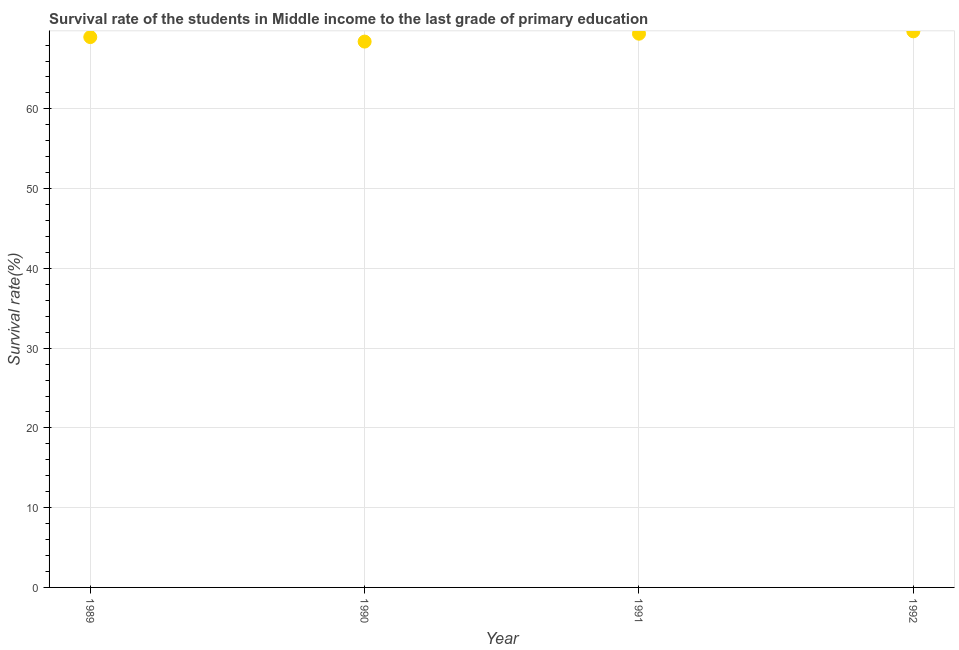What is the survival rate in primary education in 1990?
Ensure brevity in your answer.  68.44. Across all years, what is the maximum survival rate in primary education?
Your answer should be very brief. 69.72. Across all years, what is the minimum survival rate in primary education?
Your response must be concise. 68.44. In which year was the survival rate in primary education minimum?
Make the answer very short. 1990. What is the sum of the survival rate in primary education?
Offer a very short reply. 276.58. What is the difference between the survival rate in primary education in 1989 and 1991?
Offer a terse response. -0.42. What is the average survival rate in primary education per year?
Offer a very short reply. 69.15. What is the median survival rate in primary education?
Give a very brief answer. 69.21. In how many years, is the survival rate in primary education greater than 24 %?
Offer a very short reply. 4. What is the ratio of the survival rate in primary education in 1991 to that in 1992?
Provide a short and direct response. 1. Is the survival rate in primary education in 1989 less than that in 1990?
Offer a very short reply. No. What is the difference between the highest and the second highest survival rate in primary education?
Ensure brevity in your answer.  0.3. Is the sum of the survival rate in primary education in 1990 and 1991 greater than the maximum survival rate in primary education across all years?
Keep it short and to the point. Yes. What is the difference between the highest and the lowest survival rate in primary education?
Your answer should be compact. 1.29. Does the survival rate in primary education monotonically increase over the years?
Keep it short and to the point. No. How many dotlines are there?
Your answer should be very brief. 1. How many years are there in the graph?
Your answer should be very brief. 4. What is the difference between two consecutive major ticks on the Y-axis?
Provide a succinct answer. 10. Are the values on the major ticks of Y-axis written in scientific E-notation?
Provide a succinct answer. No. Does the graph contain any zero values?
Your answer should be compact. No. Does the graph contain grids?
Your response must be concise. Yes. What is the title of the graph?
Your answer should be compact. Survival rate of the students in Middle income to the last grade of primary education. What is the label or title of the X-axis?
Your response must be concise. Year. What is the label or title of the Y-axis?
Your answer should be compact. Survival rate(%). What is the Survival rate(%) in 1989?
Make the answer very short. 69. What is the Survival rate(%) in 1990?
Your answer should be compact. 68.44. What is the Survival rate(%) in 1991?
Your answer should be compact. 69.42. What is the Survival rate(%) in 1992?
Keep it short and to the point. 69.72. What is the difference between the Survival rate(%) in 1989 and 1990?
Offer a very short reply. 0.56. What is the difference between the Survival rate(%) in 1989 and 1991?
Your answer should be compact. -0.42. What is the difference between the Survival rate(%) in 1989 and 1992?
Keep it short and to the point. -0.72. What is the difference between the Survival rate(%) in 1990 and 1991?
Keep it short and to the point. -0.99. What is the difference between the Survival rate(%) in 1990 and 1992?
Provide a short and direct response. -1.29. What is the difference between the Survival rate(%) in 1991 and 1992?
Keep it short and to the point. -0.3. What is the ratio of the Survival rate(%) in 1989 to that in 1990?
Your answer should be very brief. 1.01. What is the ratio of the Survival rate(%) in 1990 to that in 1992?
Ensure brevity in your answer.  0.98. What is the ratio of the Survival rate(%) in 1991 to that in 1992?
Ensure brevity in your answer.  1. 